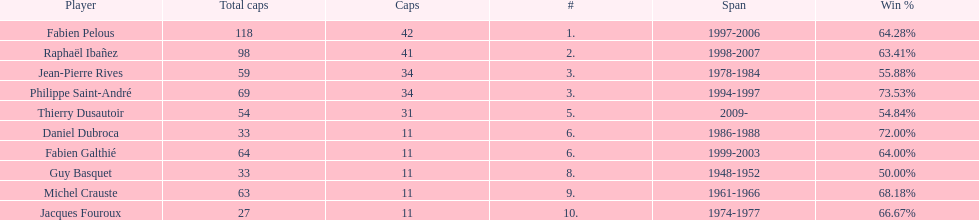Which captain served the least amount of time? Daniel Dubroca. 